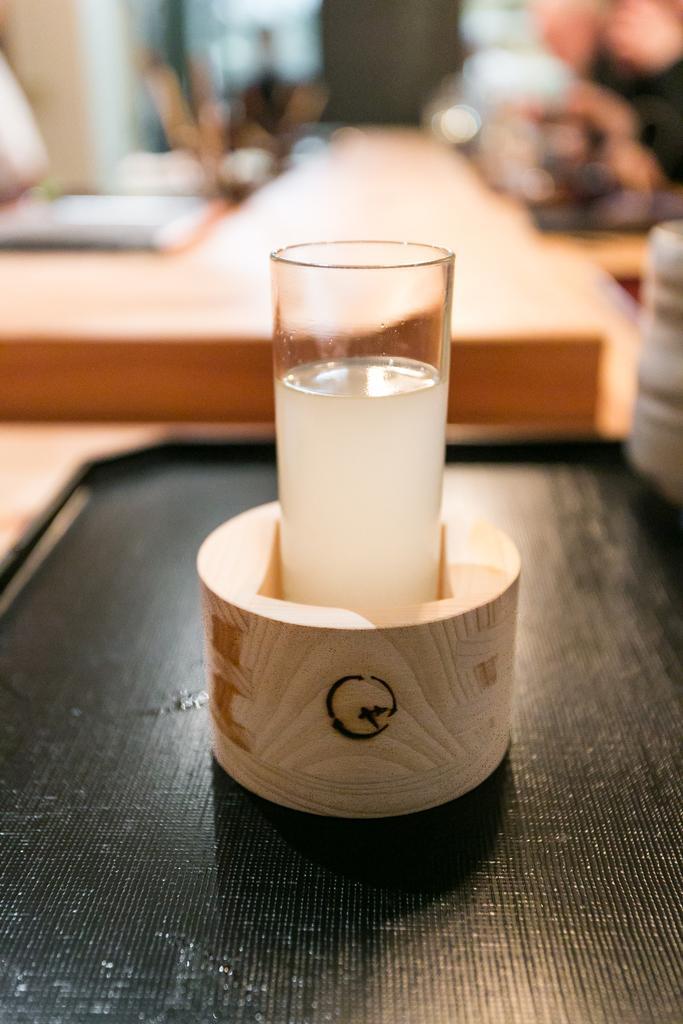How would you summarize this image in a sentence or two? In the center of the image we can see a glass with the liquid and the glass is placed in a black tray which is on the wooden table and the background of the image is blurred. 